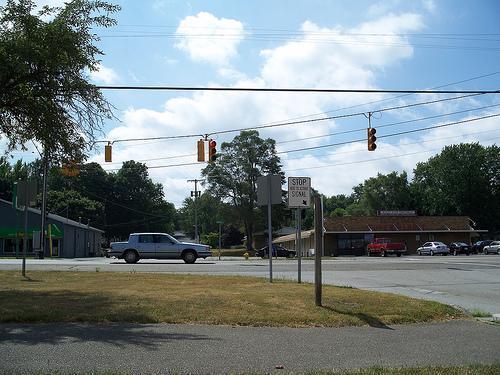How many people are visible?
Give a very brief answer. 0. 